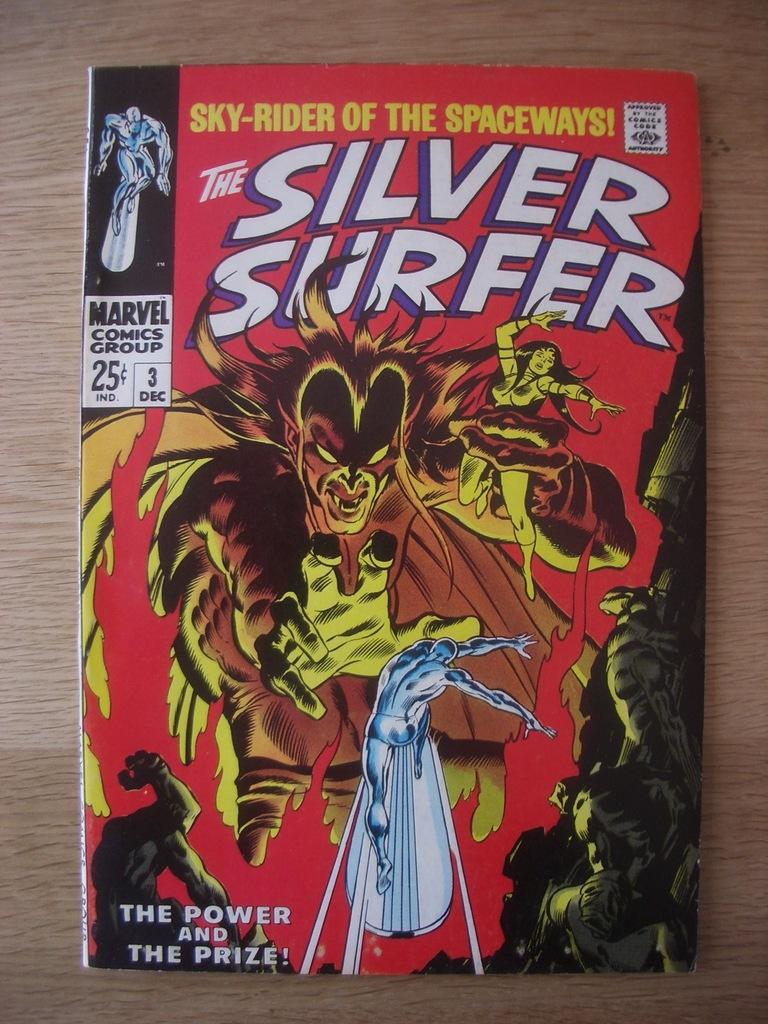<image>
Write a terse but informative summary of the picture. An issue of The Silver Surfer that originally cost 25 cents. 